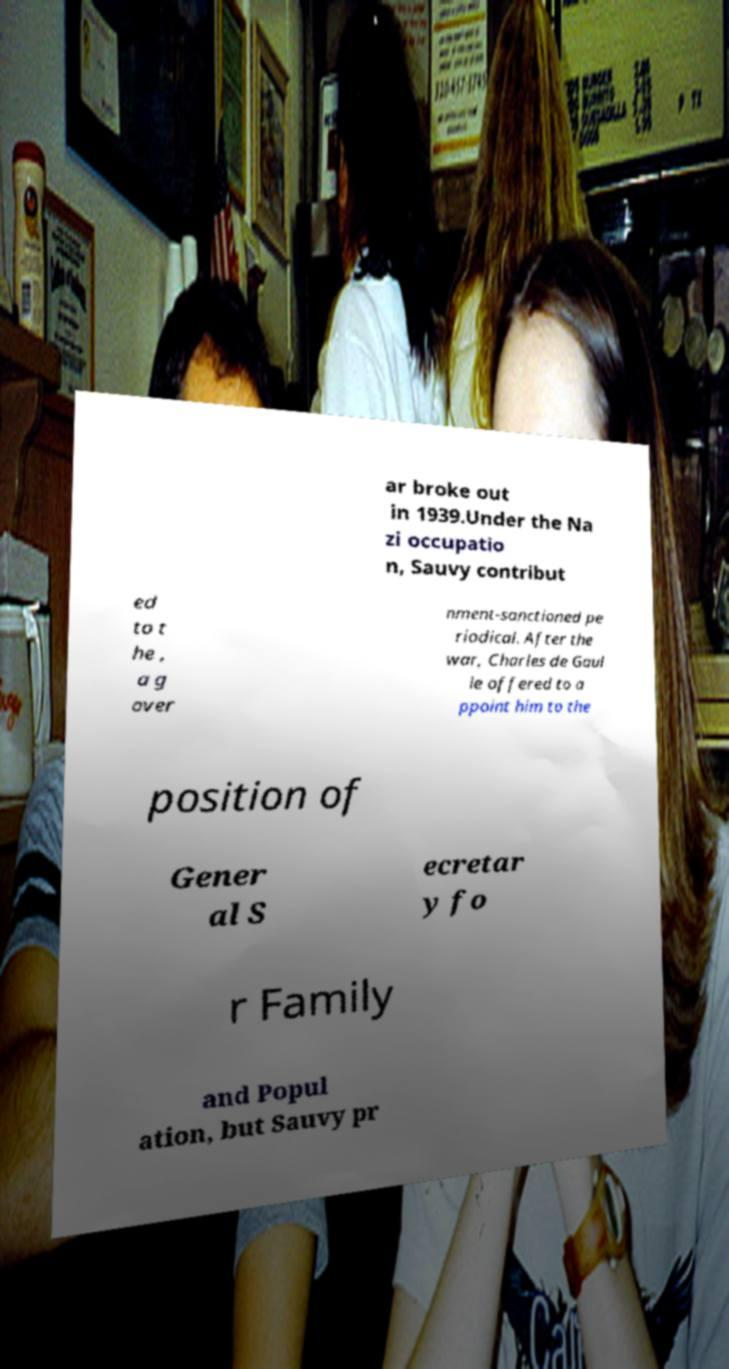What messages or text are displayed in this image? I need them in a readable, typed format. ar broke out in 1939.Under the Na zi occupatio n, Sauvy contribut ed to t he , a g over nment-sanctioned pe riodical. After the war, Charles de Gaul le offered to a ppoint him to the position of Gener al S ecretar y fo r Family and Popul ation, but Sauvy pr 